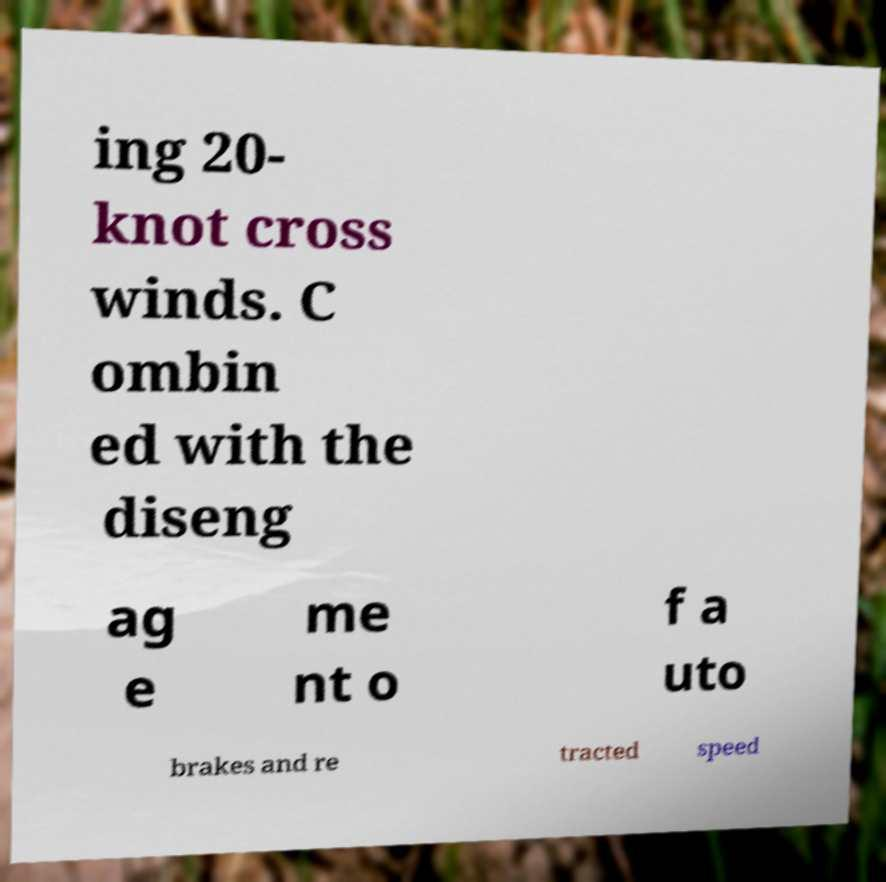Please read and relay the text visible in this image. What does it say? ing 20- knot cross winds. C ombin ed with the diseng ag e me nt o f a uto brakes and re tracted speed 